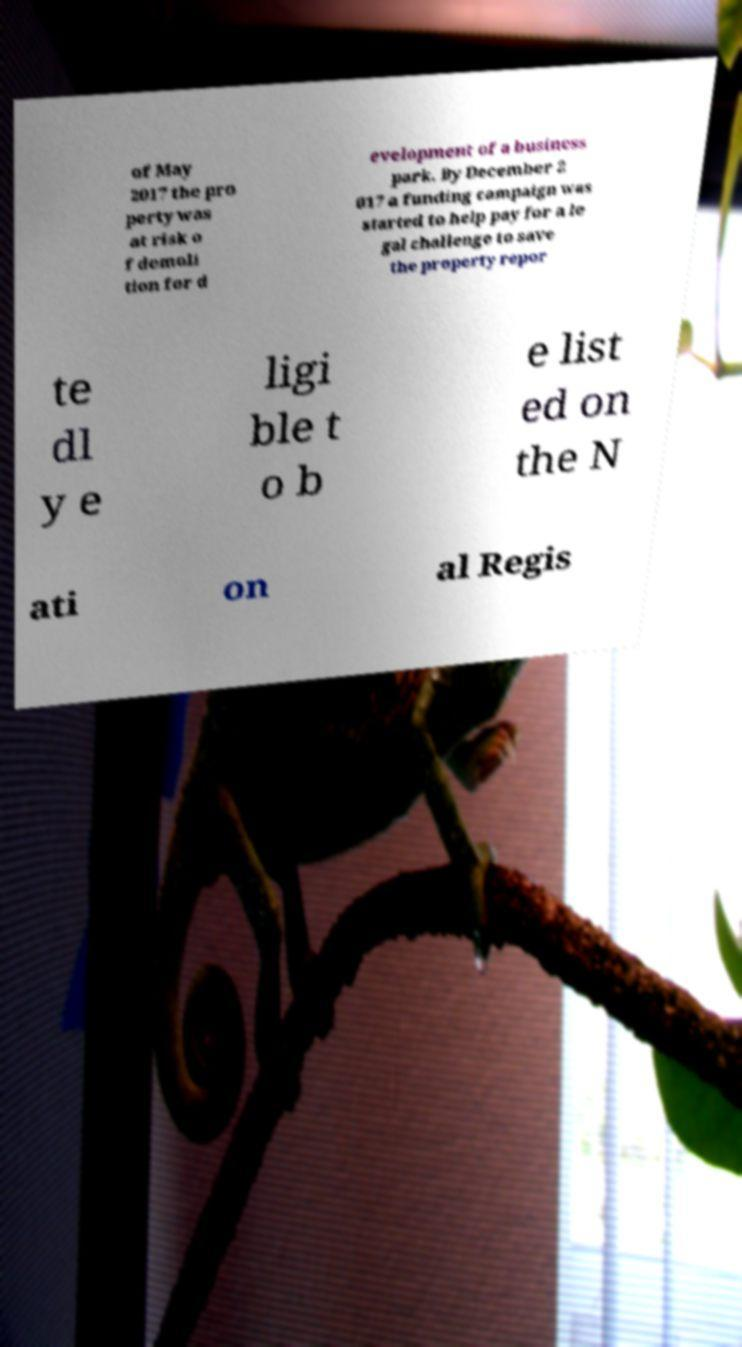Could you assist in decoding the text presented in this image and type it out clearly? of May 2017 the pro perty was at risk o f demoli tion for d evelopment of a business park. By December 2 017 a funding campaign was started to help pay for a le gal challenge to save the property repor te dl y e ligi ble t o b e list ed on the N ati on al Regis 